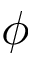Convert formula to latex. <formula><loc_0><loc_0><loc_500><loc_500>\phi</formula> 